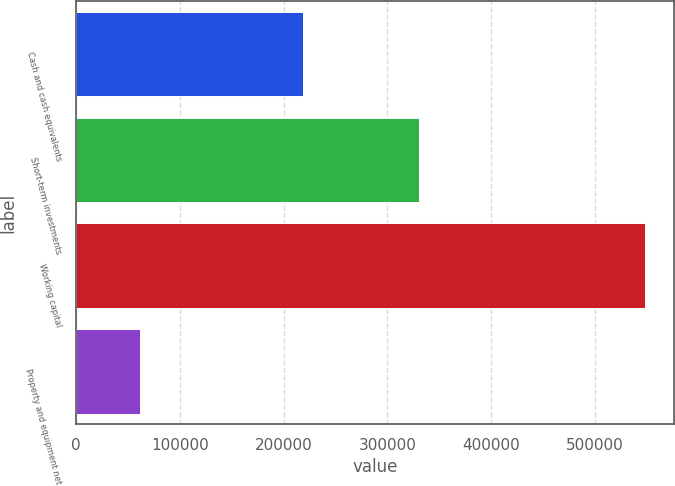Convert chart. <chart><loc_0><loc_0><loc_500><loc_500><bar_chart><fcel>Cash and cash equivalents<fcel>Short-term investments<fcel>Working capital<fcel>Property and equipment net<nl><fcel>218996<fcel>330543<fcel>548324<fcel>61983<nl></chart> 